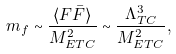<formula> <loc_0><loc_0><loc_500><loc_500>m _ { f } \sim \frac { \langle F \bar { F } \rangle } { M ^ { 2 } _ { E T C } } \sim \frac { \Lambda ^ { 3 } _ { T C } } { M ^ { 2 } _ { E T C } } ,</formula> 